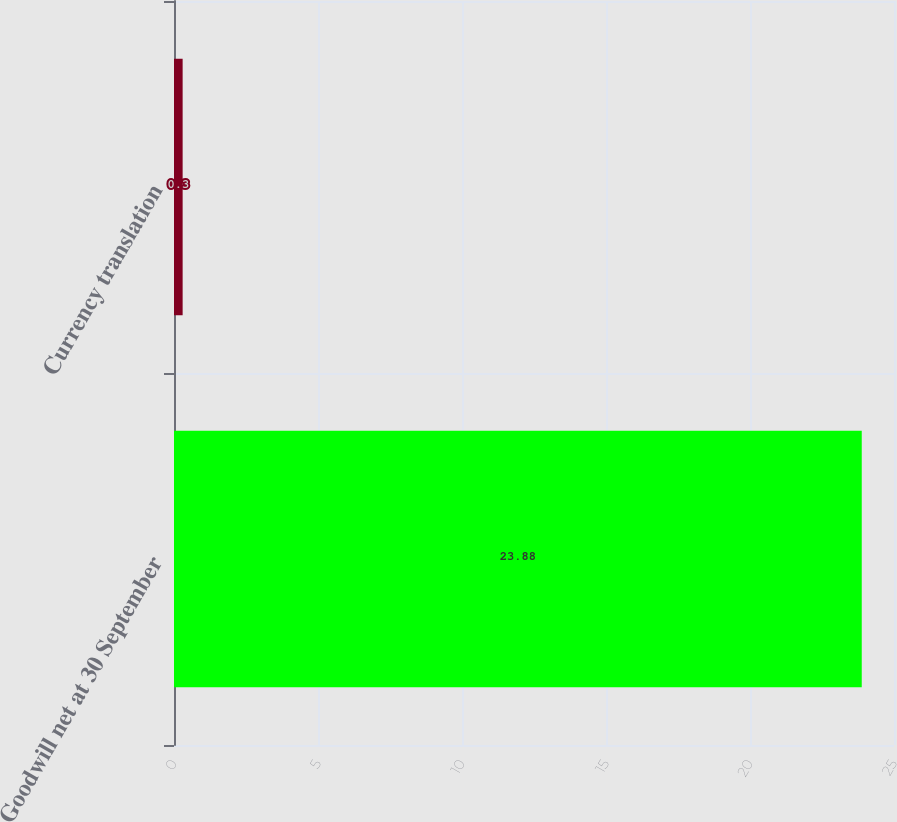Convert chart to OTSL. <chart><loc_0><loc_0><loc_500><loc_500><bar_chart><fcel>Goodwill net at 30 September<fcel>Currency translation<nl><fcel>23.88<fcel>0.3<nl></chart> 